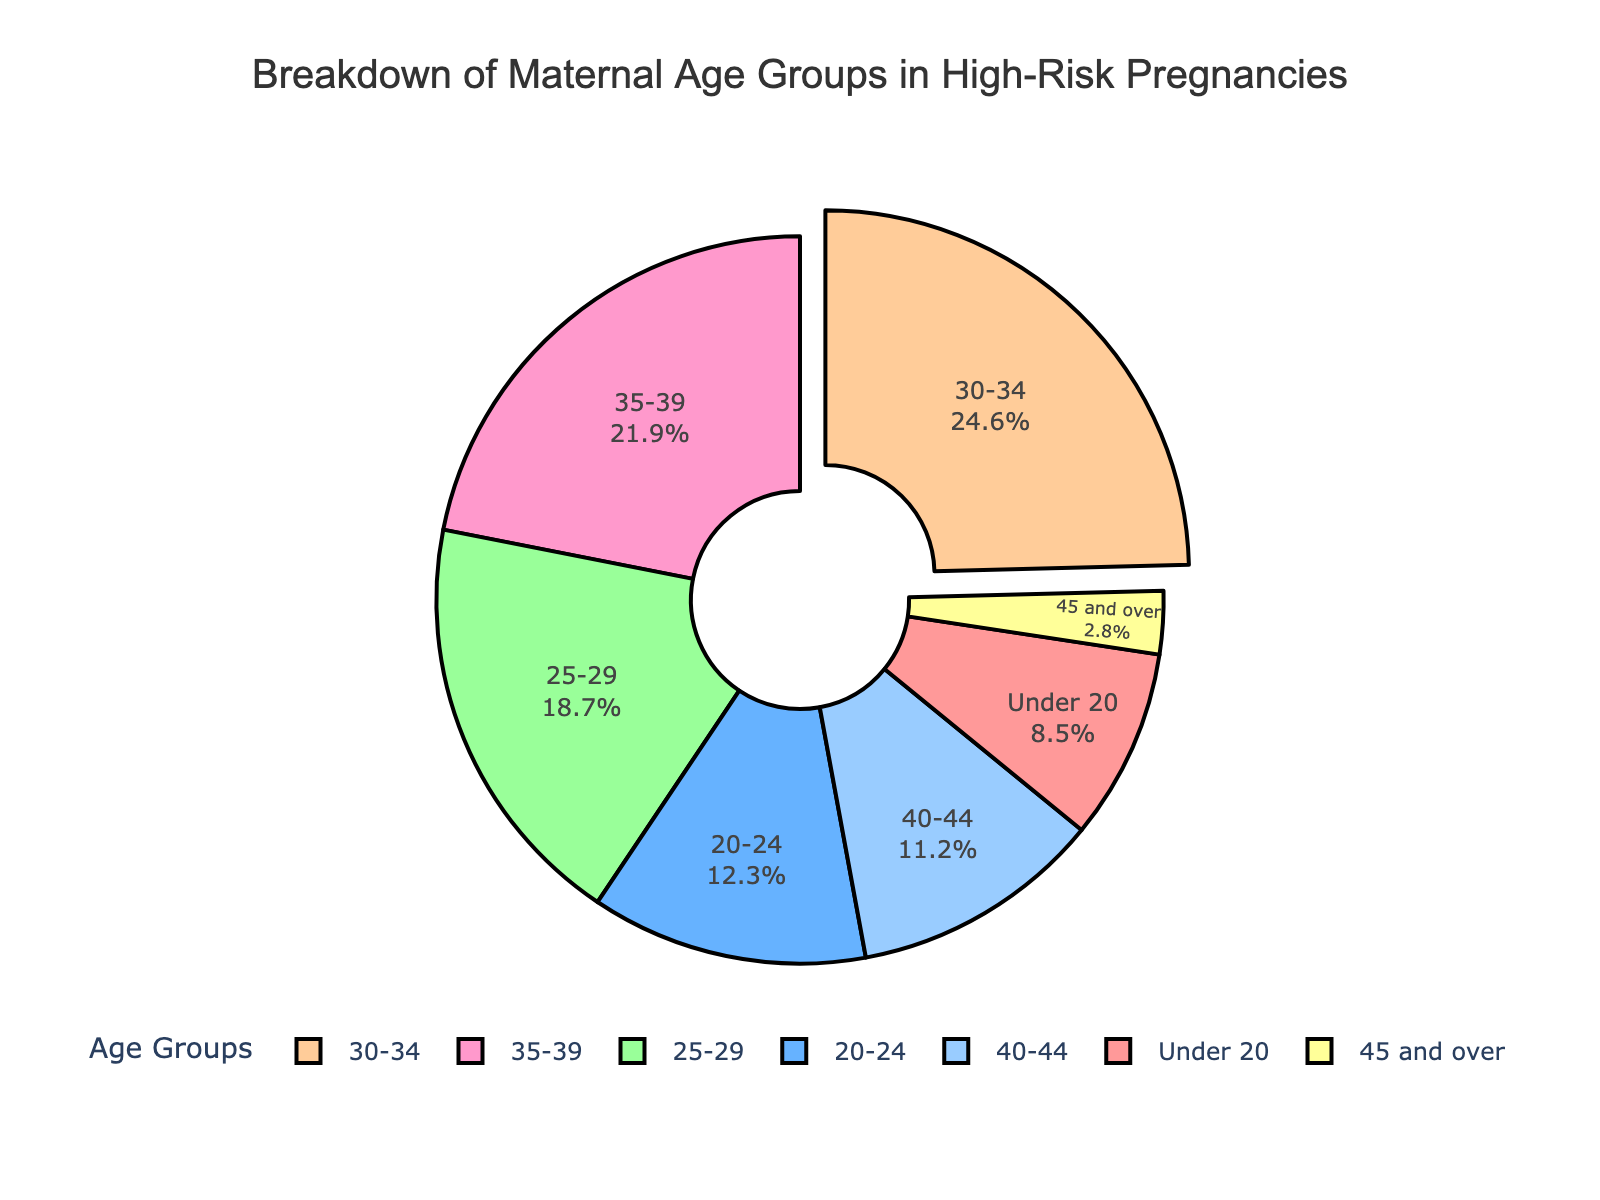What's the percentage of pregnancies in women aged 35-39? The pie chart shows the percentage next to the label for each age group. Look for the "35-39" label and read the percentage next to it.
Answer: 21.9% Which age group has the highest percentage of high-risk pregnancies? Identify the age group label with the largest section of the pie chart. This is usually marked by the segment that is pulled out of the pie chart.
Answer: 30-34 What is the combined percentage of high-risk pregnancies for women under 20 and 20-24? Add the percentages from the "Under 20" and "20-24" sections. The values are 8.5% and 12.3%. Therefore, the sum is 8.5% + 12.3%.
Answer: 20.8% Which age group has the lowest percentage of high-risk pregnancies? Look for the smallest segment in the pie chart and note the corresponding age group label and its percentage.
Answer: 45 and over How does the percentage of pregnancies in women aged 25-29 compare to those aged 40-44? Compare the sizes of the segments and their percentages for the "25-29" and "40-44" age groups. The percentage for "25-29" is 18.7%, while for "40-44" it is 11.2%.
Answer: 25-29 is higher Is the age group 25-29 represented with a yellow segment? Look at the color associated with the "25-29" age group label in the pie chart.
Answer: No What is the difference in percentage between age groups 30-34 and 35-39? Subtract the percentage of the "35-39" group from the percentage of the "30-34" group. The values are 24.6% and 21.9%, respectively. Thus, 24.6% - 21.9%.
Answer: 2.7% What percentage of high-risk pregnancies are in women aged 40 and over? Add the percentages of the "40-44" and "45 and over" sections. The values are 11.2% and 2.8%. Therefore, the sum is 11.2% + 2.8%.
Answer: 14% Which age group is represented in light blue color? Identify the segment in the pie chart that is colored light blue and note the age group label.
Answer: 20-24 Are the percentages of high-risk pregnancies in the age groups 25-29 and 30-34 almost equal? Compare the percentages for "25-29" (18.7%) and "30-34" (24.6%). Consider if the difference is small or significant.
Answer: No 